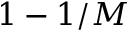<formula> <loc_0><loc_0><loc_500><loc_500>1 - 1 / M</formula> 